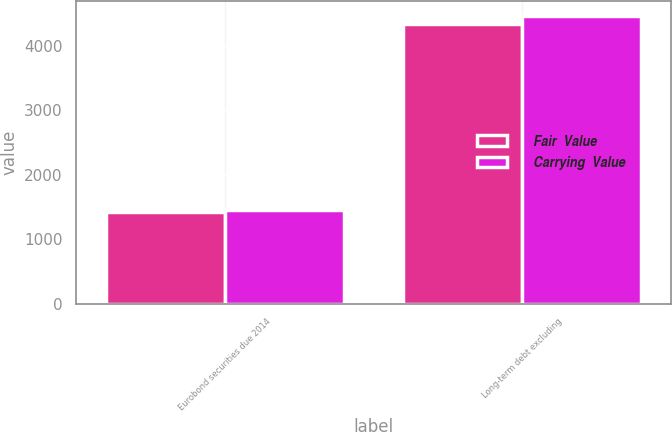Convert chart to OTSL. <chart><loc_0><loc_0><loc_500><loc_500><stacked_bar_chart><ecel><fcel>Eurobond securities due 2014<fcel>Long-term debt excluding<nl><fcel>Fair  Value<fcel>1424<fcel>4326<nl><fcel>Carrying  Value<fcel>1447<fcel>4463<nl></chart> 